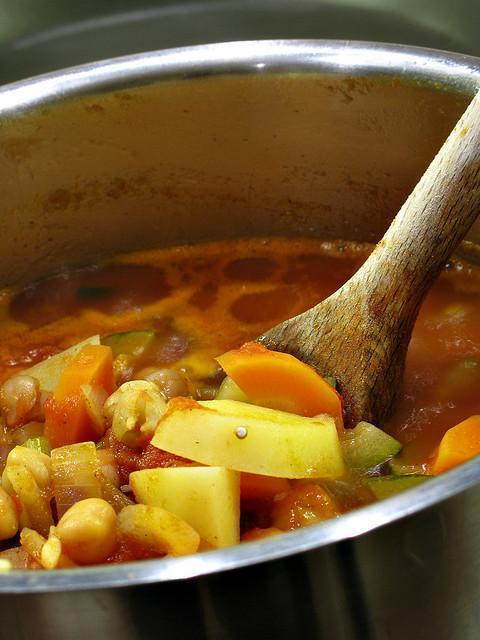How many carrots are there?
Give a very brief answer. 3. How many giraffes are there?
Give a very brief answer. 0. 